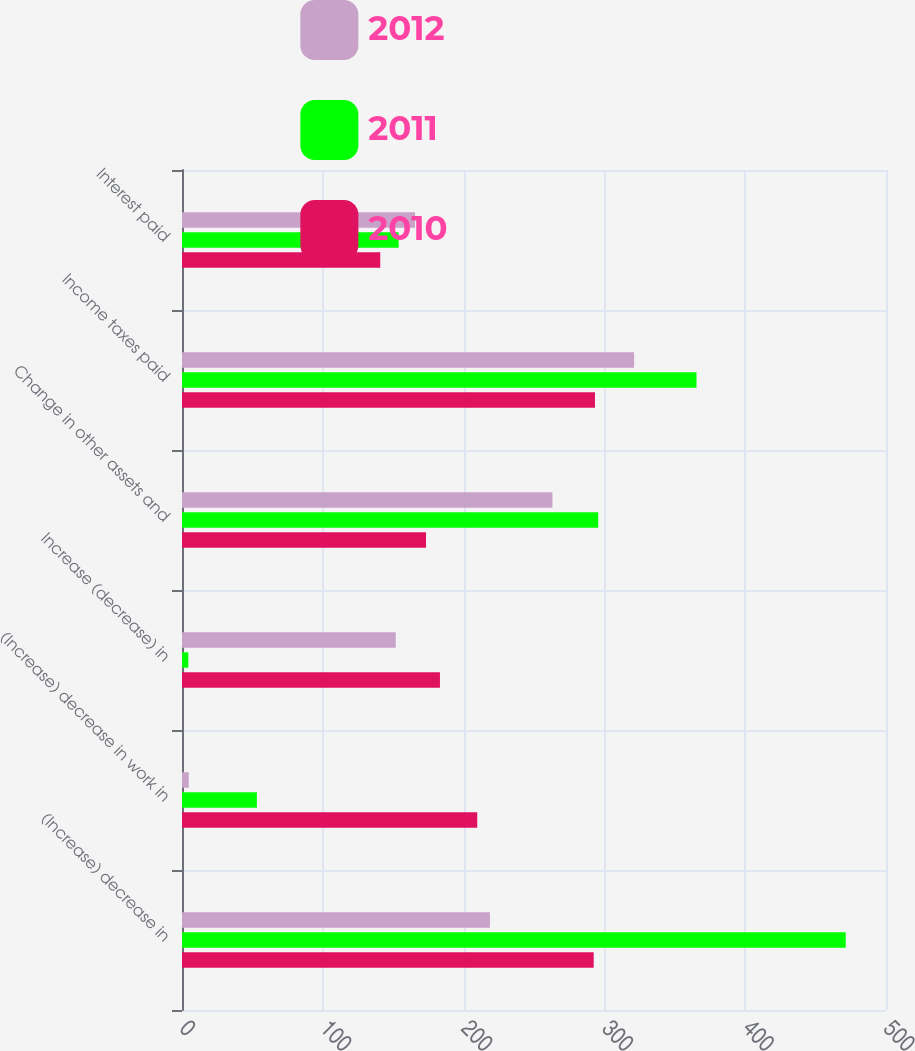<chart> <loc_0><loc_0><loc_500><loc_500><stacked_bar_chart><ecel><fcel>(Increase) decrease in<fcel>(Increase) decrease in work in<fcel>Increase (decrease) in<fcel>Change in other assets and<fcel>Income taxes paid<fcel>Interest paid<nl><fcel>2012<fcel>218.7<fcel>4.8<fcel>151.8<fcel>263.1<fcel>321.1<fcel>165.5<nl><fcel>2011<fcel>471.4<fcel>53.2<fcel>4.5<fcel>295.6<fcel>365.4<fcel>153.9<nl><fcel>2010<fcel>292.4<fcel>209.7<fcel>183.2<fcel>173.3<fcel>293.3<fcel>140.8<nl></chart> 